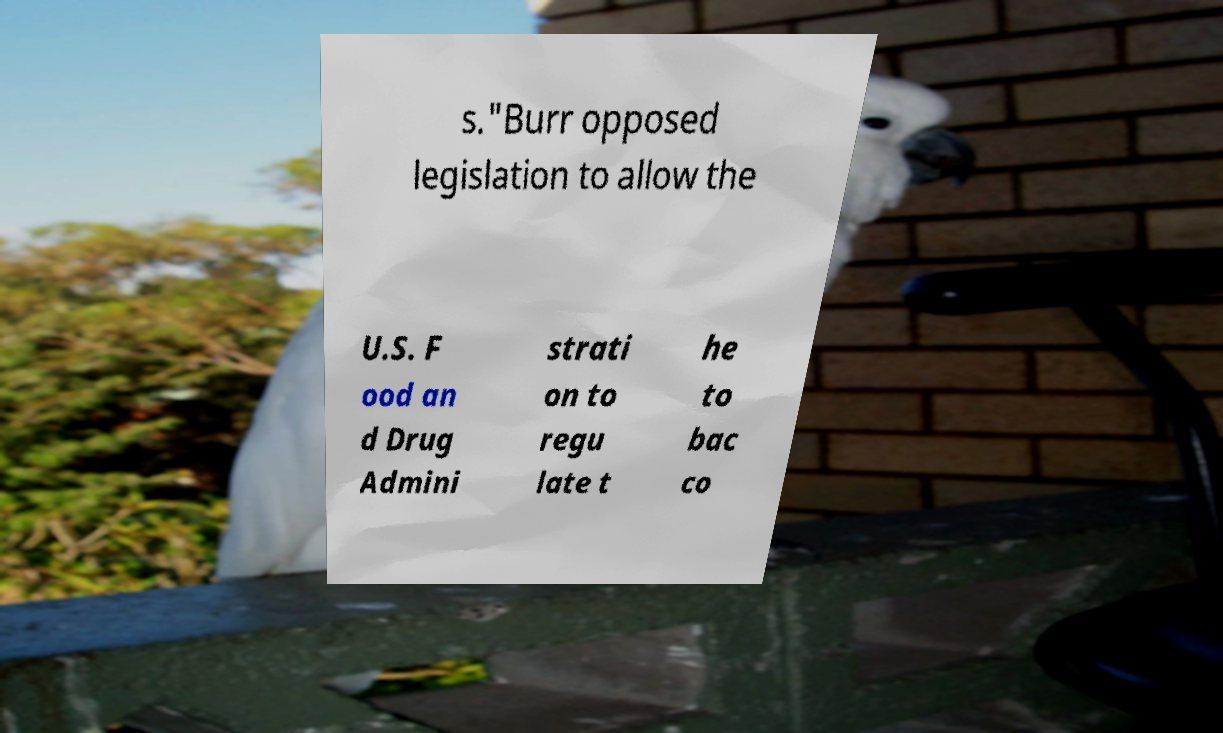Can you read and provide the text displayed in the image?This photo seems to have some interesting text. Can you extract and type it out for me? s."Burr opposed legislation to allow the U.S. F ood an d Drug Admini strati on to regu late t he to bac co 